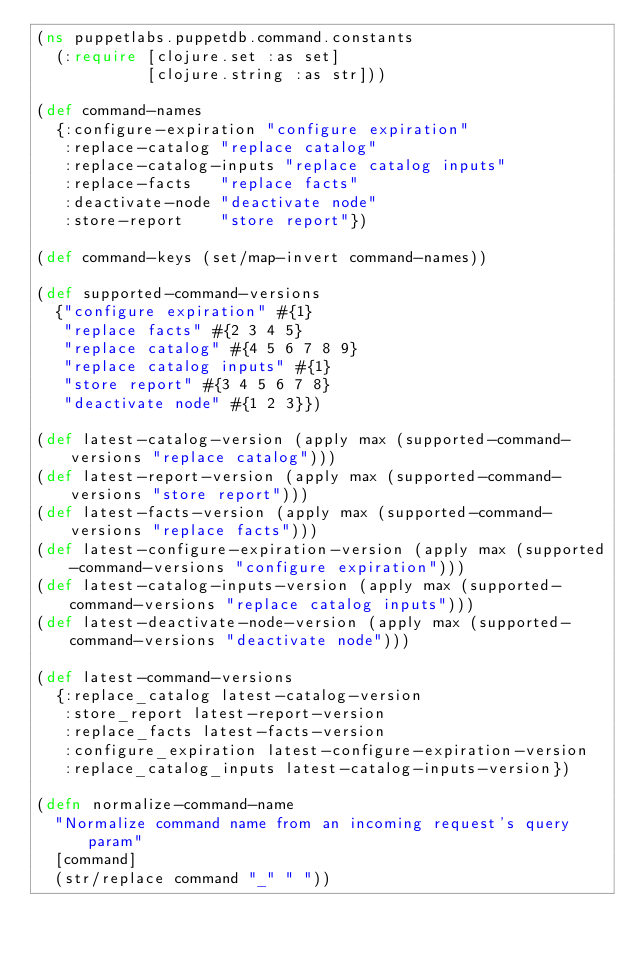<code> <loc_0><loc_0><loc_500><loc_500><_Clojure_>(ns puppetlabs.puppetdb.command.constants
  (:require [clojure.set :as set]
            [clojure.string :as str]))

(def command-names
  {:configure-expiration "configure expiration"
   :replace-catalog "replace catalog"
   :replace-catalog-inputs "replace catalog inputs"
   :replace-facts   "replace facts"
   :deactivate-node "deactivate node"
   :store-report    "store report"})

(def command-keys (set/map-invert command-names))

(def supported-command-versions
  {"configure expiration" #{1}
   "replace facts" #{2 3 4 5}
   "replace catalog" #{4 5 6 7 8 9}
   "replace catalog inputs" #{1}
   "store report" #{3 4 5 6 7 8}
   "deactivate node" #{1 2 3}})

(def latest-catalog-version (apply max (supported-command-versions "replace catalog")))
(def latest-report-version (apply max (supported-command-versions "store report")))
(def latest-facts-version (apply max (supported-command-versions "replace facts")))
(def latest-configure-expiration-version (apply max (supported-command-versions "configure expiration")))
(def latest-catalog-inputs-version (apply max (supported-command-versions "replace catalog inputs")))
(def latest-deactivate-node-version (apply max (supported-command-versions "deactivate node")))

(def latest-command-versions
  {:replace_catalog latest-catalog-version
   :store_report latest-report-version
   :replace_facts latest-facts-version
   :configure_expiration latest-configure-expiration-version
   :replace_catalog_inputs latest-catalog-inputs-version})

(defn normalize-command-name
  "Normalize command name from an incoming request's query param"
  [command]
  (str/replace command "_" " "))
</code> 